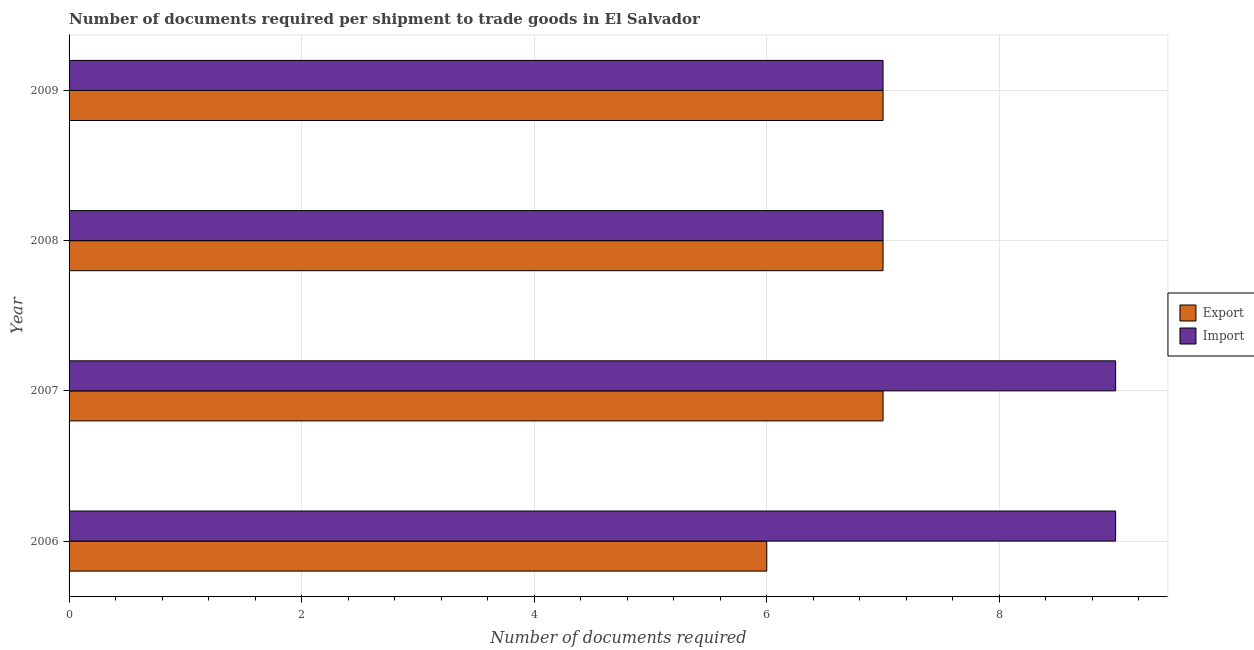How many groups of bars are there?
Ensure brevity in your answer.  4. Are the number of bars on each tick of the Y-axis equal?
Offer a very short reply. Yes. How many bars are there on the 1st tick from the top?
Keep it short and to the point. 2. What is the number of documents required to import goods in 2009?
Keep it short and to the point. 7. Across all years, what is the maximum number of documents required to import goods?
Your response must be concise. 9. Across all years, what is the minimum number of documents required to export goods?
Keep it short and to the point. 6. In which year was the number of documents required to export goods maximum?
Make the answer very short. 2007. In which year was the number of documents required to import goods minimum?
Provide a succinct answer. 2008. What is the total number of documents required to import goods in the graph?
Provide a succinct answer. 32. What is the difference between the number of documents required to import goods in 2007 and that in 2009?
Ensure brevity in your answer.  2. What is the difference between the number of documents required to import goods in 2009 and the number of documents required to export goods in 2006?
Ensure brevity in your answer.  1. What is the average number of documents required to export goods per year?
Your response must be concise. 6.75. In the year 2009, what is the difference between the number of documents required to import goods and number of documents required to export goods?
Offer a terse response. 0. What is the ratio of the number of documents required to import goods in 2006 to that in 2007?
Ensure brevity in your answer.  1. Is the number of documents required to import goods in 2006 less than that in 2008?
Keep it short and to the point. No. Is the difference between the number of documents required to import goods in 2006 and 2008 greater than the difference between the number of documents required to export goods in 2006 and 2008?
Make the answer very short. Yes. What is the difference between the highest and the second highest number of documents required to export goods?
Offer a terse response. 0. What is the difference between the highest and the lowest number of documents required to import goods?
Keep it short and to the point. 2. Is the sum of the number of documents required to import goods in 2008 and 2009 greater than the maximum number of documents required to export goods across all years?
Give a very brief answer. Yes. What does the 2nd bar from the top in 2007 represents?
Offer a very short reply. Export. What does the 1st bar from the bottom in 2009 represents?
Offer a terse response. Export. How many bars are there?
Your answer should be compact. 8. Are all the bars in the graph horizontal?
Your answer should be compact. Yes. What is the difference between two consecutive major ticks on the X-axis?
Your answer should be compact. 2. Are the values on the major ticks of X-axis written in scientific E-notation?
Your answer should be compact. No. Does the graph contain grids?
Keep it short and to the point. Yes. How many legend labels are there?
Your answer should be very brief. 2. What is the title of the graph?
Provide a short and direct response. Number of documents required per shipment to trade goods in El Salvador. Does "GDP" appear as one of the legend labels in the graph?
Provide a short and direct response. No. What is the label or title of the X-axis?
Offer a very short reply. Number of documents required. What is the label or title of the Y-axis?
Your answer should be compact. Year. What is the Number of documents required of Import in 2006?
Provide a short and direct response. 9. What is the Number of documents required of Export in 2007?
Ensure brevity in your answer.  7. What is the Number of documents required of Export in 2008?
Your answer should be compact. 7. What is the Number of documents required in Export in 2009?
Offer a very short reply. 7. Across all years, what is the maximum Number of documents required in Export?
Ensure brevity in your answer.  7. What is the total Number of documents required in Import in the graph?
Offer a very short reply. 32. What is the difference between the Number of documents required of Export in 2006 and that in 2007?
Keep it short and to the point. -1. What is the difference between the Number of documents required in Import in 2006 and that in 2007?
Offer a very short reply. 0. What is the difference between the Number of documents required of Export in 2006 and that in 2008?
Provide a short and direct response. -1. What is the difference between the Number of documents required of Import in 2007 and that in 2008?
Ensure brevity in your answer.  2. What is the difference between the Number of documents required of Import in 2007 and that in 2009?
Ensure brevity in your answer.  2. What is the difference between the Number of documents required of Export in 2008 and that in 2009?
Your answer should be compact. 0. What is the difference between the Number of documents required of Export in 2006 and the Number of documents required of Import in 2009?
Your response must be concise. -1. What is the difference between the Number of documents required in Export in 2007 and the Number of documents required in Import in 2008?
Provide a short and direct response. 0. What is the difference between the Number of documents required in Export in 2008 and the Number of documents required in Import in 2009?
Provide a succinct answer. 0. What is the average Number of documents required of Export per year?
Offer a very short reply. 6.75. In the year 2006, what is the difference between the Number of documents required in Export and Number of documents required in Import?
Offer a terse response. -3. In the year 2009, what is the difference between the Number of documents required in Export and Number of documents required in Import?
Your answer should be compact. 0. What is the ratio of the Number of documents required of Export in 2006 to that in 2007?
Offer a terse response. 0.86. What is the ratio of the Number of documents required in Import in 2006 to that in 2007?
Keep it short and to the point. 1. What is the ratio of the Number of documents required of Export in 2006 to that in 2008?
Offer a very short reply. 0.86. What is the ratio of the Number of documents required in Export in 2007 to that in 2009?
Your answer should be compact. 1. What is the ratio of the Number of documents required in Import in 2008 to that in 2009?
Provide a succinct answer. 1. What is the difference between the highest and the second highest Number of documents required in Import?
Your response must be concise. 0. What is the difference between the highest and the lowest Number of documents required in Export?
Provide a succinct answer. 1. 